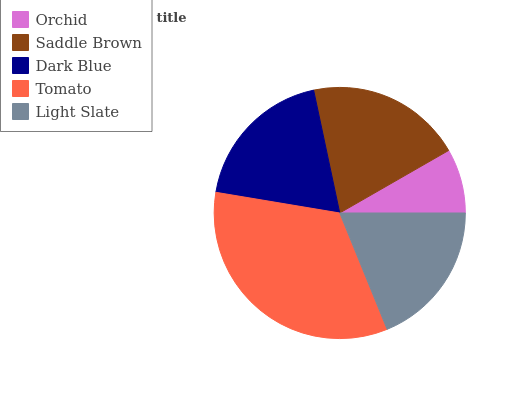Is Orchid the minimum?
Answer yes or no. Yes. Is Tomato the maximum?
Answer yes or no. Yes. Is Saddle Brown the minimum?
Answer yes or no. No. Is Saddle Brown the maximum?
Answer yes or no. No. Is Saddle Brown greater than Orchid?
Answer yes or no. Yes. Is Orchid less than Saddle Brown?
Answer yes or no. Yes. Is Orchid greater than Saddle Brown?
Answer yes or no. No. Is Saddle Brown less than Orchid?
Answer yes or no. No. Is Dark Blue the high median?
Answer yes or no. Yes. Is Dark Blue the low median?
Answer yes or no. Yes. Is Tomato the high median?
Answer yes or no. No. Is Orchid the low median?
Answer yes or no. No. 